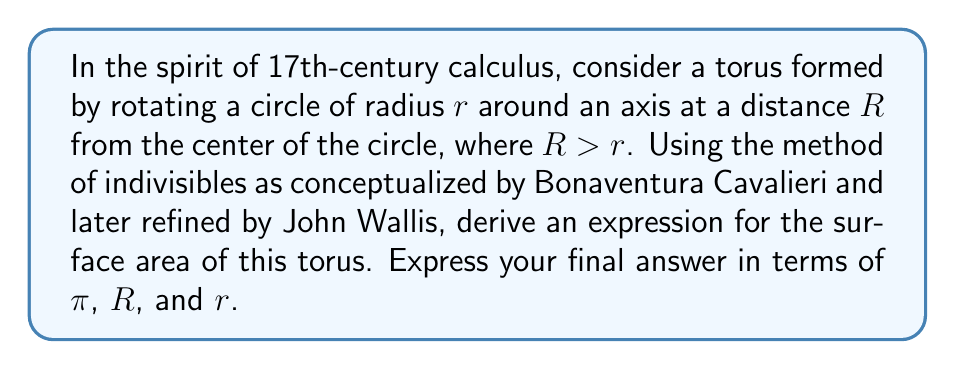Show me your answer to this math problem. Let's approach this problem using the methods available in the 17th century:

1) First, we'll consider the torus as composed of infinitesimal circular strips. Each strip can be thought of as the surface of a very thin cylinder.

2) The radius of each strip varies as we move around the torus. At any point, it can be expressed as:

   $$R + r\cos\theta$$

   where $\theta$ is the angle from the horizontal plane through the center of the tube.

3) The height of each strip is infinitesimal and can be expressed as $r d\theta$.

4) The surface area of each strip is therefore:

   $$dA = 2\pi(R + r\cos\theta) \cdot r d\theta$$

5) To find the total surface area, we need to sum (integrate) these strips over the full circle:

   $$A = \int_0^{2\pi} 2\pi r(R + r\cos\theta) d\theta$$

6) Expanding the integrand:

   $$A = \int_0^{2\pi} (2\pi rR + 2\pi r^2\cos\theta) d\theta$$

7) Integrating term by term:

   $$A = [2\pi rR\theta + 2\pi r^2\sin\theta]_0^{2\pi}$$

8) Evaluating the definite integral:

   $$A = (4\pi^2 rR + 0) - (0 + 0) = 4\pi^2 rR$$

This result gives us the surface area of the torus in terms of $\pi$, $R$, and $r$.
Answer: The surface area of the torus is $A = 4\pi^2 rR$. 